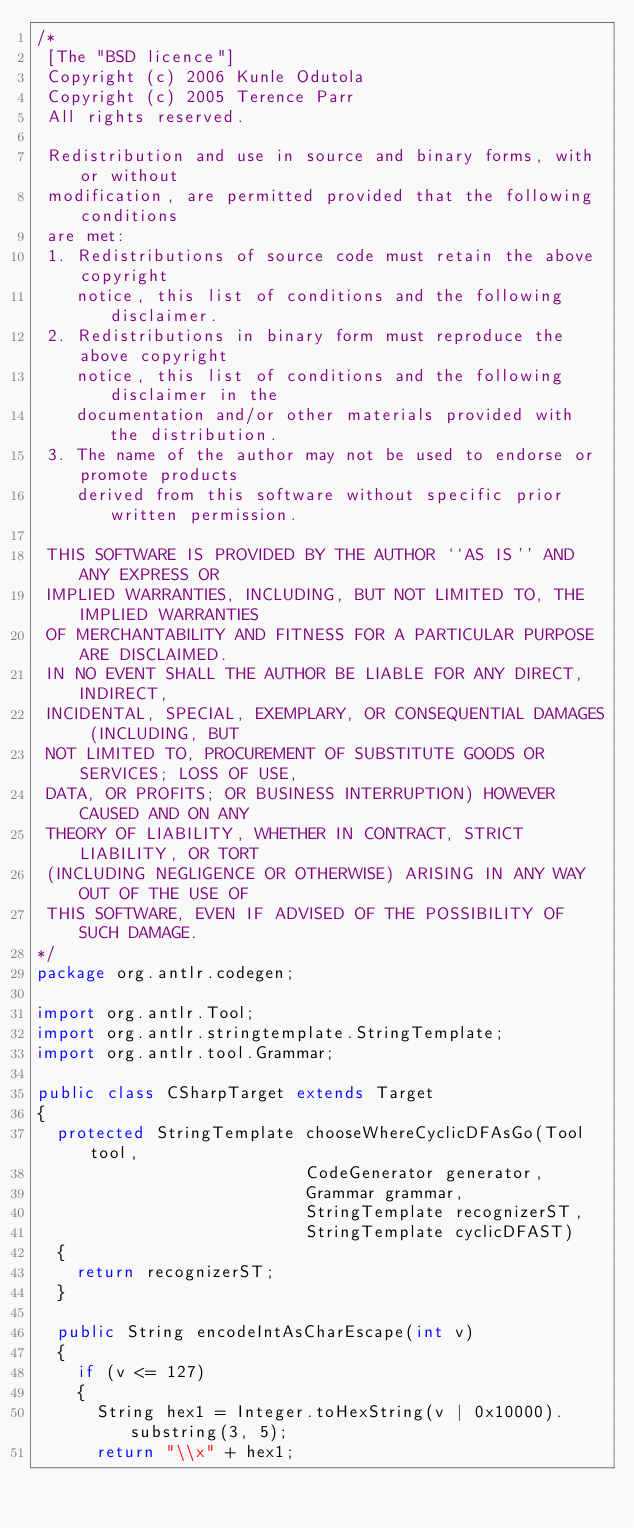<code> <loc_0><loc_0><loc_500><loc_500><_Java_>/*
 [The "BSD licence"]
 Copyright (c) 2006 Kunle Odutola
 Copyright (c) 2005 Terence Parr
 All rights reserved.

 Redistribution and use in source and binary forms, with or without
 modification, are permitted provided that the following conditions
 are met:
 1. Redistributions of source code must retain the above copyright
    notice, this list of conditions and the following disclaimer.
 2. Redistributions in binary form must reproduce the above copyright
    notice, this list of conditions and the following disclaimer in the
    documentation and/or other materials provided with the distribution.
 3. The name of the author may not be used to endorse or promote products
    derived from this software without specific prior written permission.

 THIS SOFTWARE IS PROVIDED BY THE AUTHOR ``AS IS'' AND ANY EXPRESS OR
 IMPLIED WARRANTIES, INCLUDING, BUT NOT LIMITED TO, THE IMPLIED WARRANTIES
 OF MERCHANTABILITY AND FITNESS FOR A PARTICULAR PURPOSE ARE DISCLAIMED.
 IN NO EVENT SHALL THE AUTHOR BE LIABLE FOR ANY DIRECT, INDIRECT,
 INCIDENTAL, SPECIAL, EXEMPLARY, OR CONSEQUENTIAL DAMAGES (INCLUDING, BUT
 NOT LIMITED TO, PROCUREMENT OF SUBSTITUTE GOODS OR SERVICES; LOSS OF USE,
 DATA, OR PROFITS; OR BUSINESS INTERRUPTION) HOWEVER CAUSED AND ON ANY
 THEORY OF LIABILITY, WHETHER IN CONTRACT, STRICT LIABILITY, OR TORT
 (INCLUDING NEGLIGENCE OR OTHERWISE) ARISING IN ANY WAY OUT OF THE USE OF
 THIS SOFTWARE, EVEN IF ADVISED OF THE POSSIBILITY OF SUCH DAMAGE.
*/
package org.antlr.codegen;

import org.antlr.Tool;
import org.antlr.stringtemplate.StringTemplate;
import org.antlr.tool.Grammar;

public class CSharpTarget extends Target 
{
	protected StringTemplate chooseWhereCyclicDFAsGo(Tool tool,
													 CodeGenerator generator,
													 Grammar grammar,
													 StringTemplate recognizerST,
													 StringTemplate cyclicDFAST)
	{
		return recognizerST;
	}

	public String encodeIntAsCharEscape(int v)
	{
		if (v <= 127)
		{
			String hex1 = Integer.toHexString(v | 0x10000).substring(3, 5);
			return "\\x" + hex1;</code> 